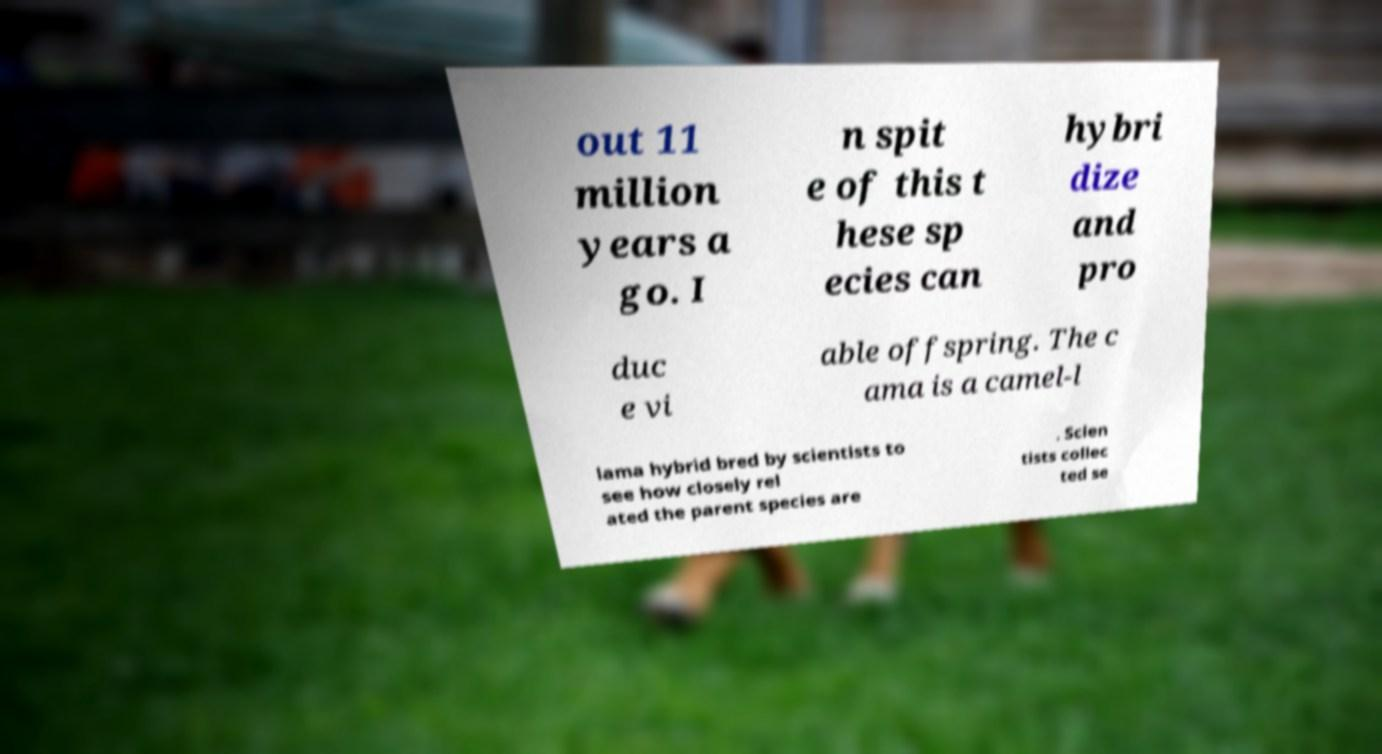Please read and relay the text visible in this image. What does it say? out 11 million years a go. I n spit e of this t hese sp ecies can hybri dize and pro duc e vi able offspring. The c ama is a camel-l lama hybrid bred by scientists to see how closely rel ated the parent species are . Scien tists collec ted se 